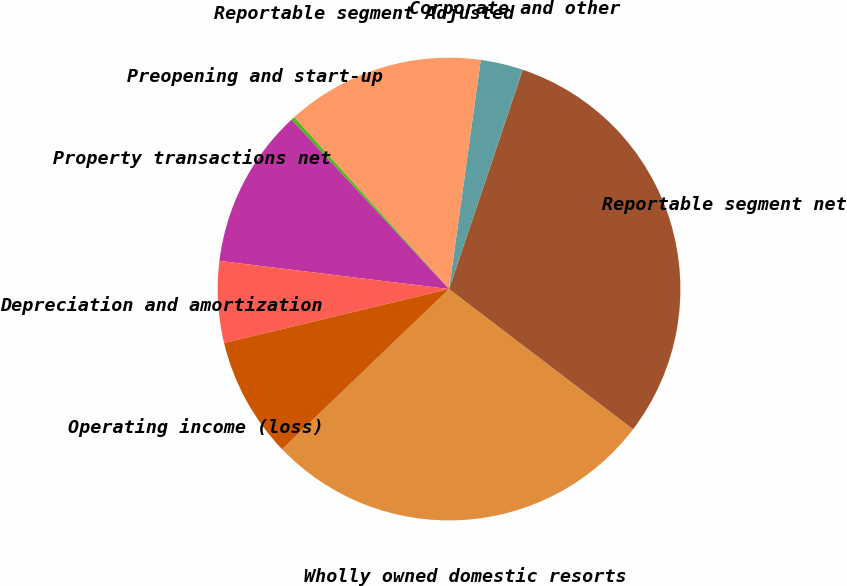Convert chart to OTSL. <chart><loc_0><loc_0><loc_500><loc_500><pie_chart><fcel>Wholly owned domestic resorts<fcel>Reportable segment net<fcel>Corporate and other<fcel>Reportable segment Adjusted<fcel>Preopening and start-up<fcel>Property transactions net<fcel>Depreciation and amortization<fcel>Operating income (loss)<nl><fcel>27.47%<fcel>30.2%<fcel>2.97%<fcel>13.86%<fcel>0.25%<fcel>11.14%<fcel>5.69%<fcel>8.42%<nl></chart> 